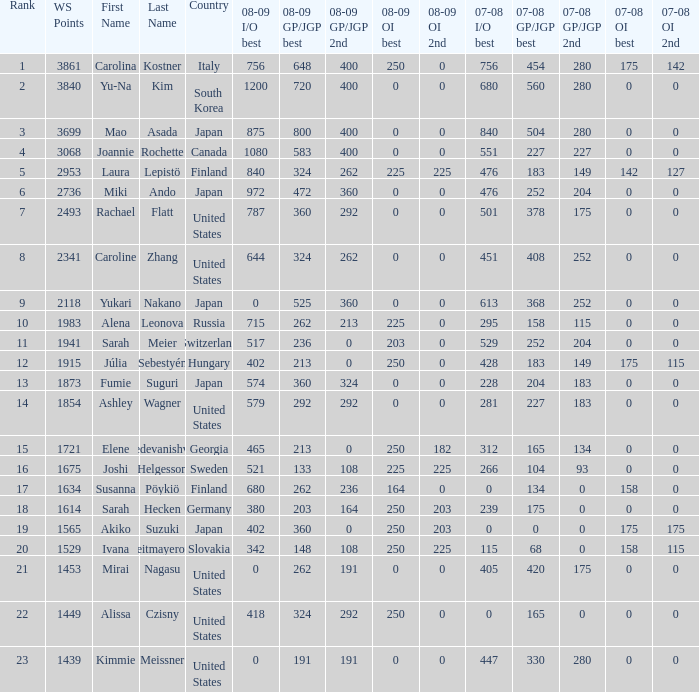08-09 gp/jgp 2nd is 213 and ws points will be what maximum 1983.0. 